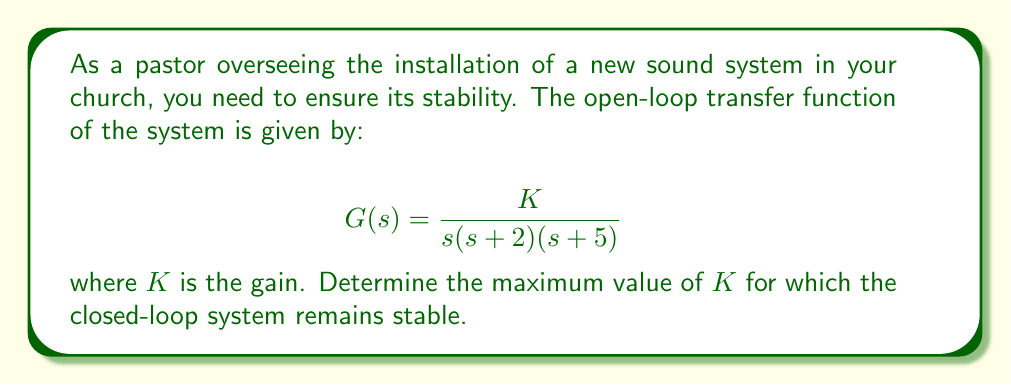Can you answer this question? To determine the stability of the closed-loop system, we'll use the Routh-Hurwitz stability criterion. First, let's derive the closed-loop transfer function:

$$T(s) = \frac{G(s)}{1 + G(s)} = \frac{K}{s(s+2)(s+5) + K}$$

The characteristic equation is:

$$s(s+2)(s+5) + K = 0$$

Expanding this:

$$s^3 + 7s^2 + 10s + K = 0$$

Now, let's construct the Routh array:

$$\begin{array}{c|cc}
s^3 & 1 & 10 \\
s^2 & 7 & K \\
s^1 & \frac{70-K}{7} & 0 \\
s^0 & K & 0
\end{array}$$

For stability, all elements in the first column must be positive. We already know that 1 and 7 are positive, so we need:

1) $\frac{70-K}{7} > 0$, which means $K < 70$
2) $K > 0$

Combining these conditions, we get:

$$0 < K < 70$$

Therefore, the maximum value of $K$ for which the system remains stable is just under 70.
Answer: The maximum value of $K$ for which the closed-loop system remains stable is 70 (exclusive). 